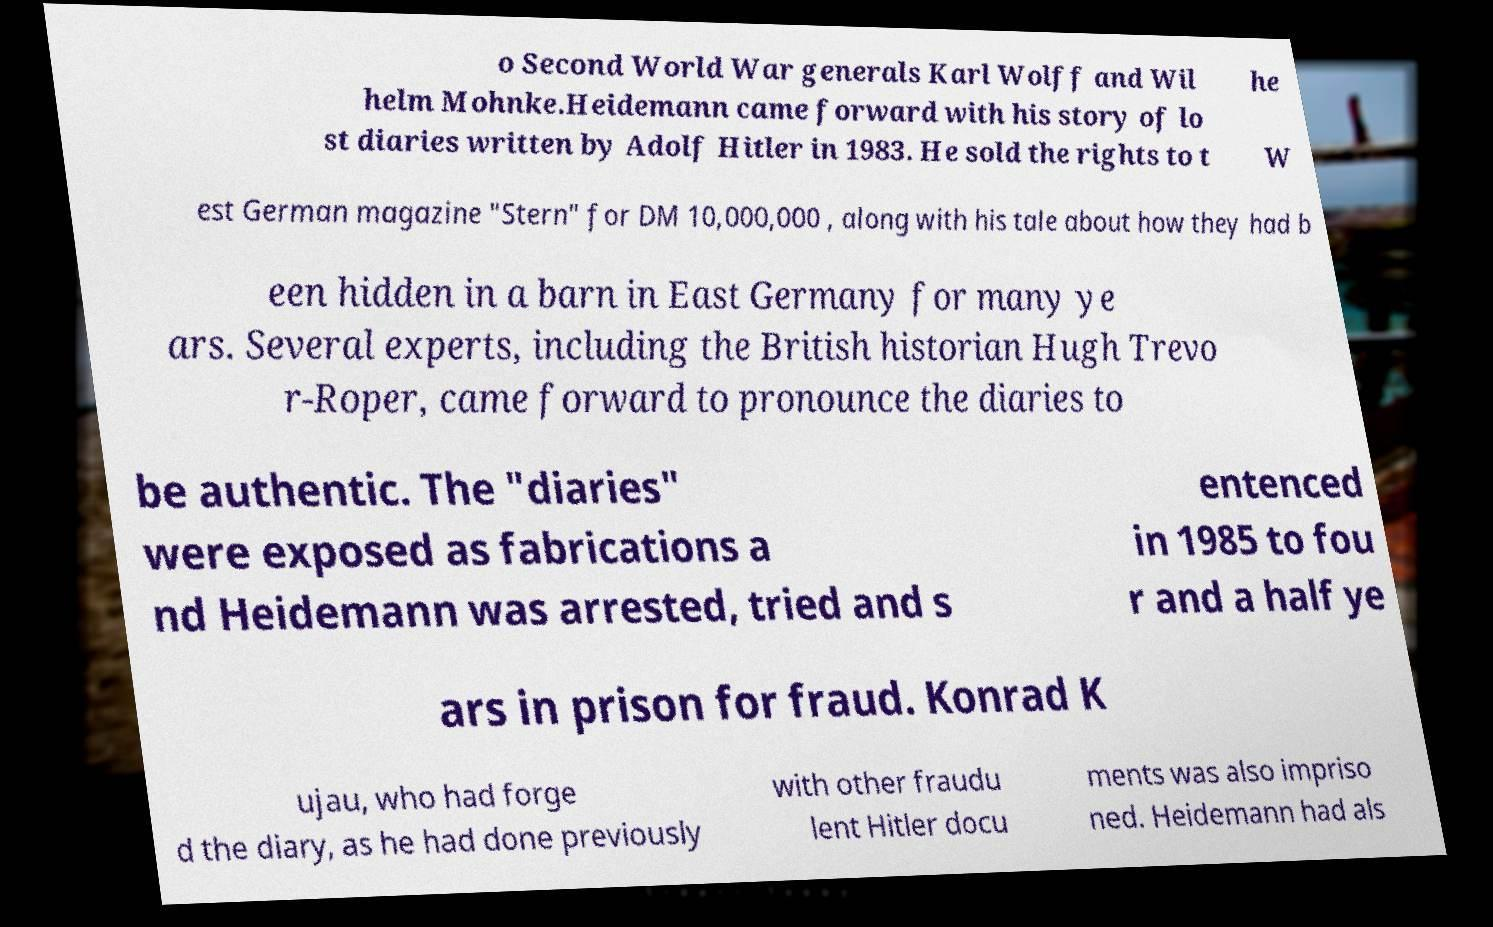There's text embedded in this image that I need extracted. Can you transcribe it verbatim? o Second World War generals Karl Wolff and Wil helm Mohnke.Heidemann came forward with his story of lo st diaries written by Adolf Hitler in 1983. He sold the rights to t he W est German magazine "Stern" for DM 10,000,000 , along with his tale about how they had b een hidden in a barn in East Germany for many ye ars. Several experts, including the British historian Hugh Trevo r-Roper, came forward to pronounce the diaries to be authentic. The "diaries" were exposed as fabrications a nd Heidemann was arrested, tried and s entenced in 1985 to fou r and a half ye ars in prison for fraud. Konrad K ujau, who had forge d the diary, as he had done previously with other fraudu lent Hitler docu ments was also impriso ned. Heidemann had als 